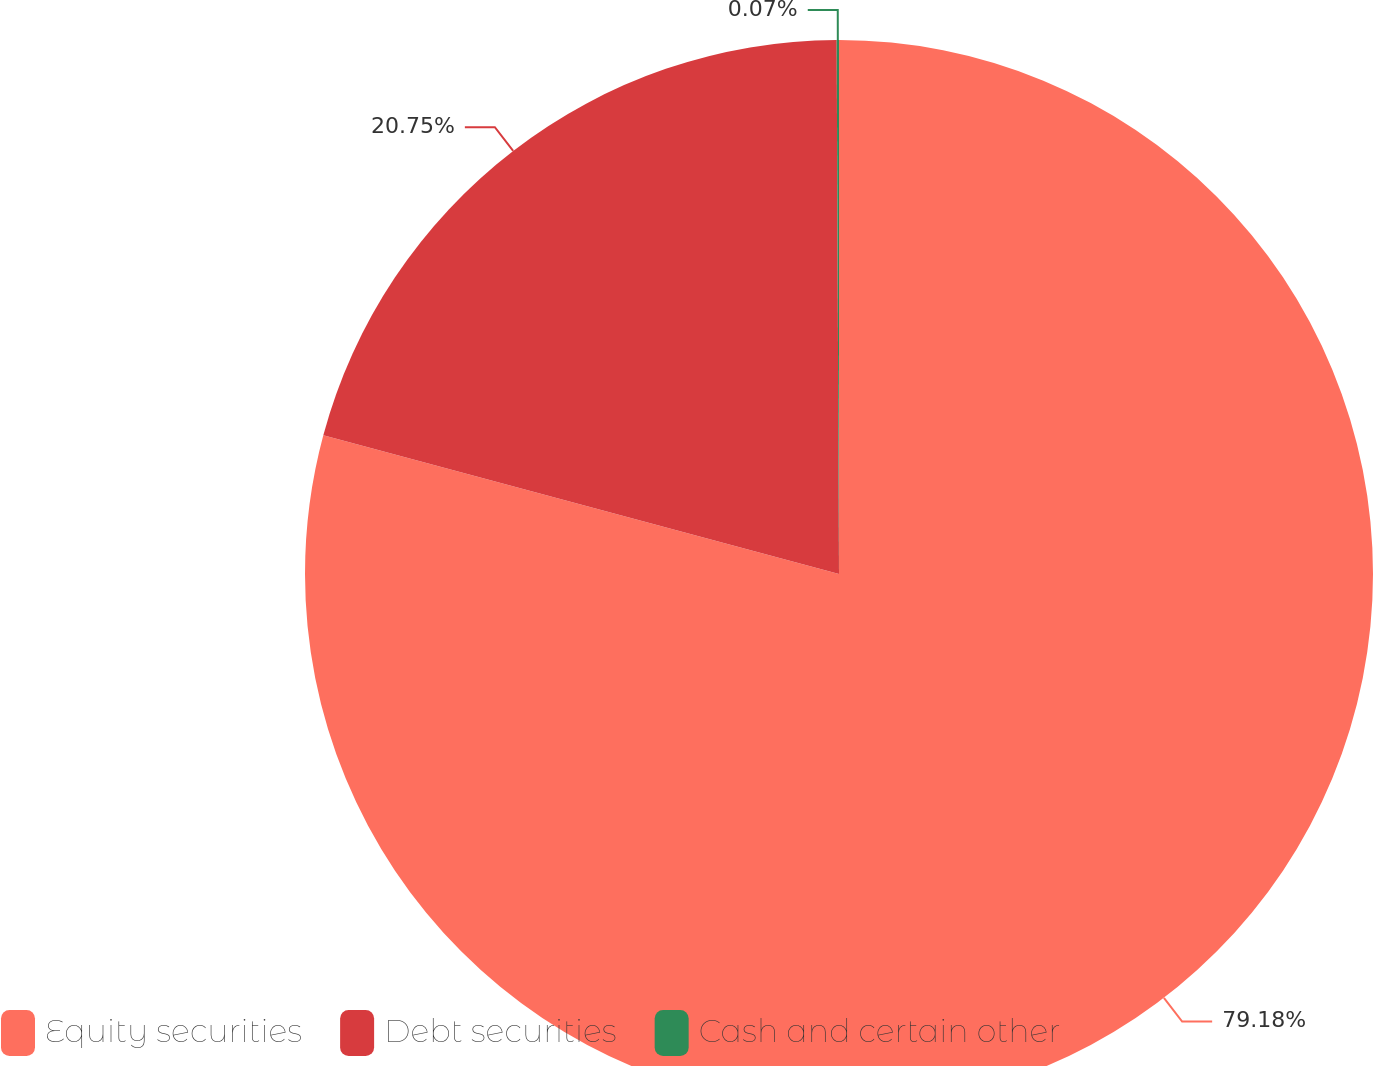Convert chart to OTSL. <chart><loc_0><loc_0><loc_500><loc_500><pie_chart><fcel>Equity securities<fcel>Debt securities<fcel>Cash and certain other<nl><fcel>79.18%<fcel>20.75%<fcel>0.07%<nl></chart> 